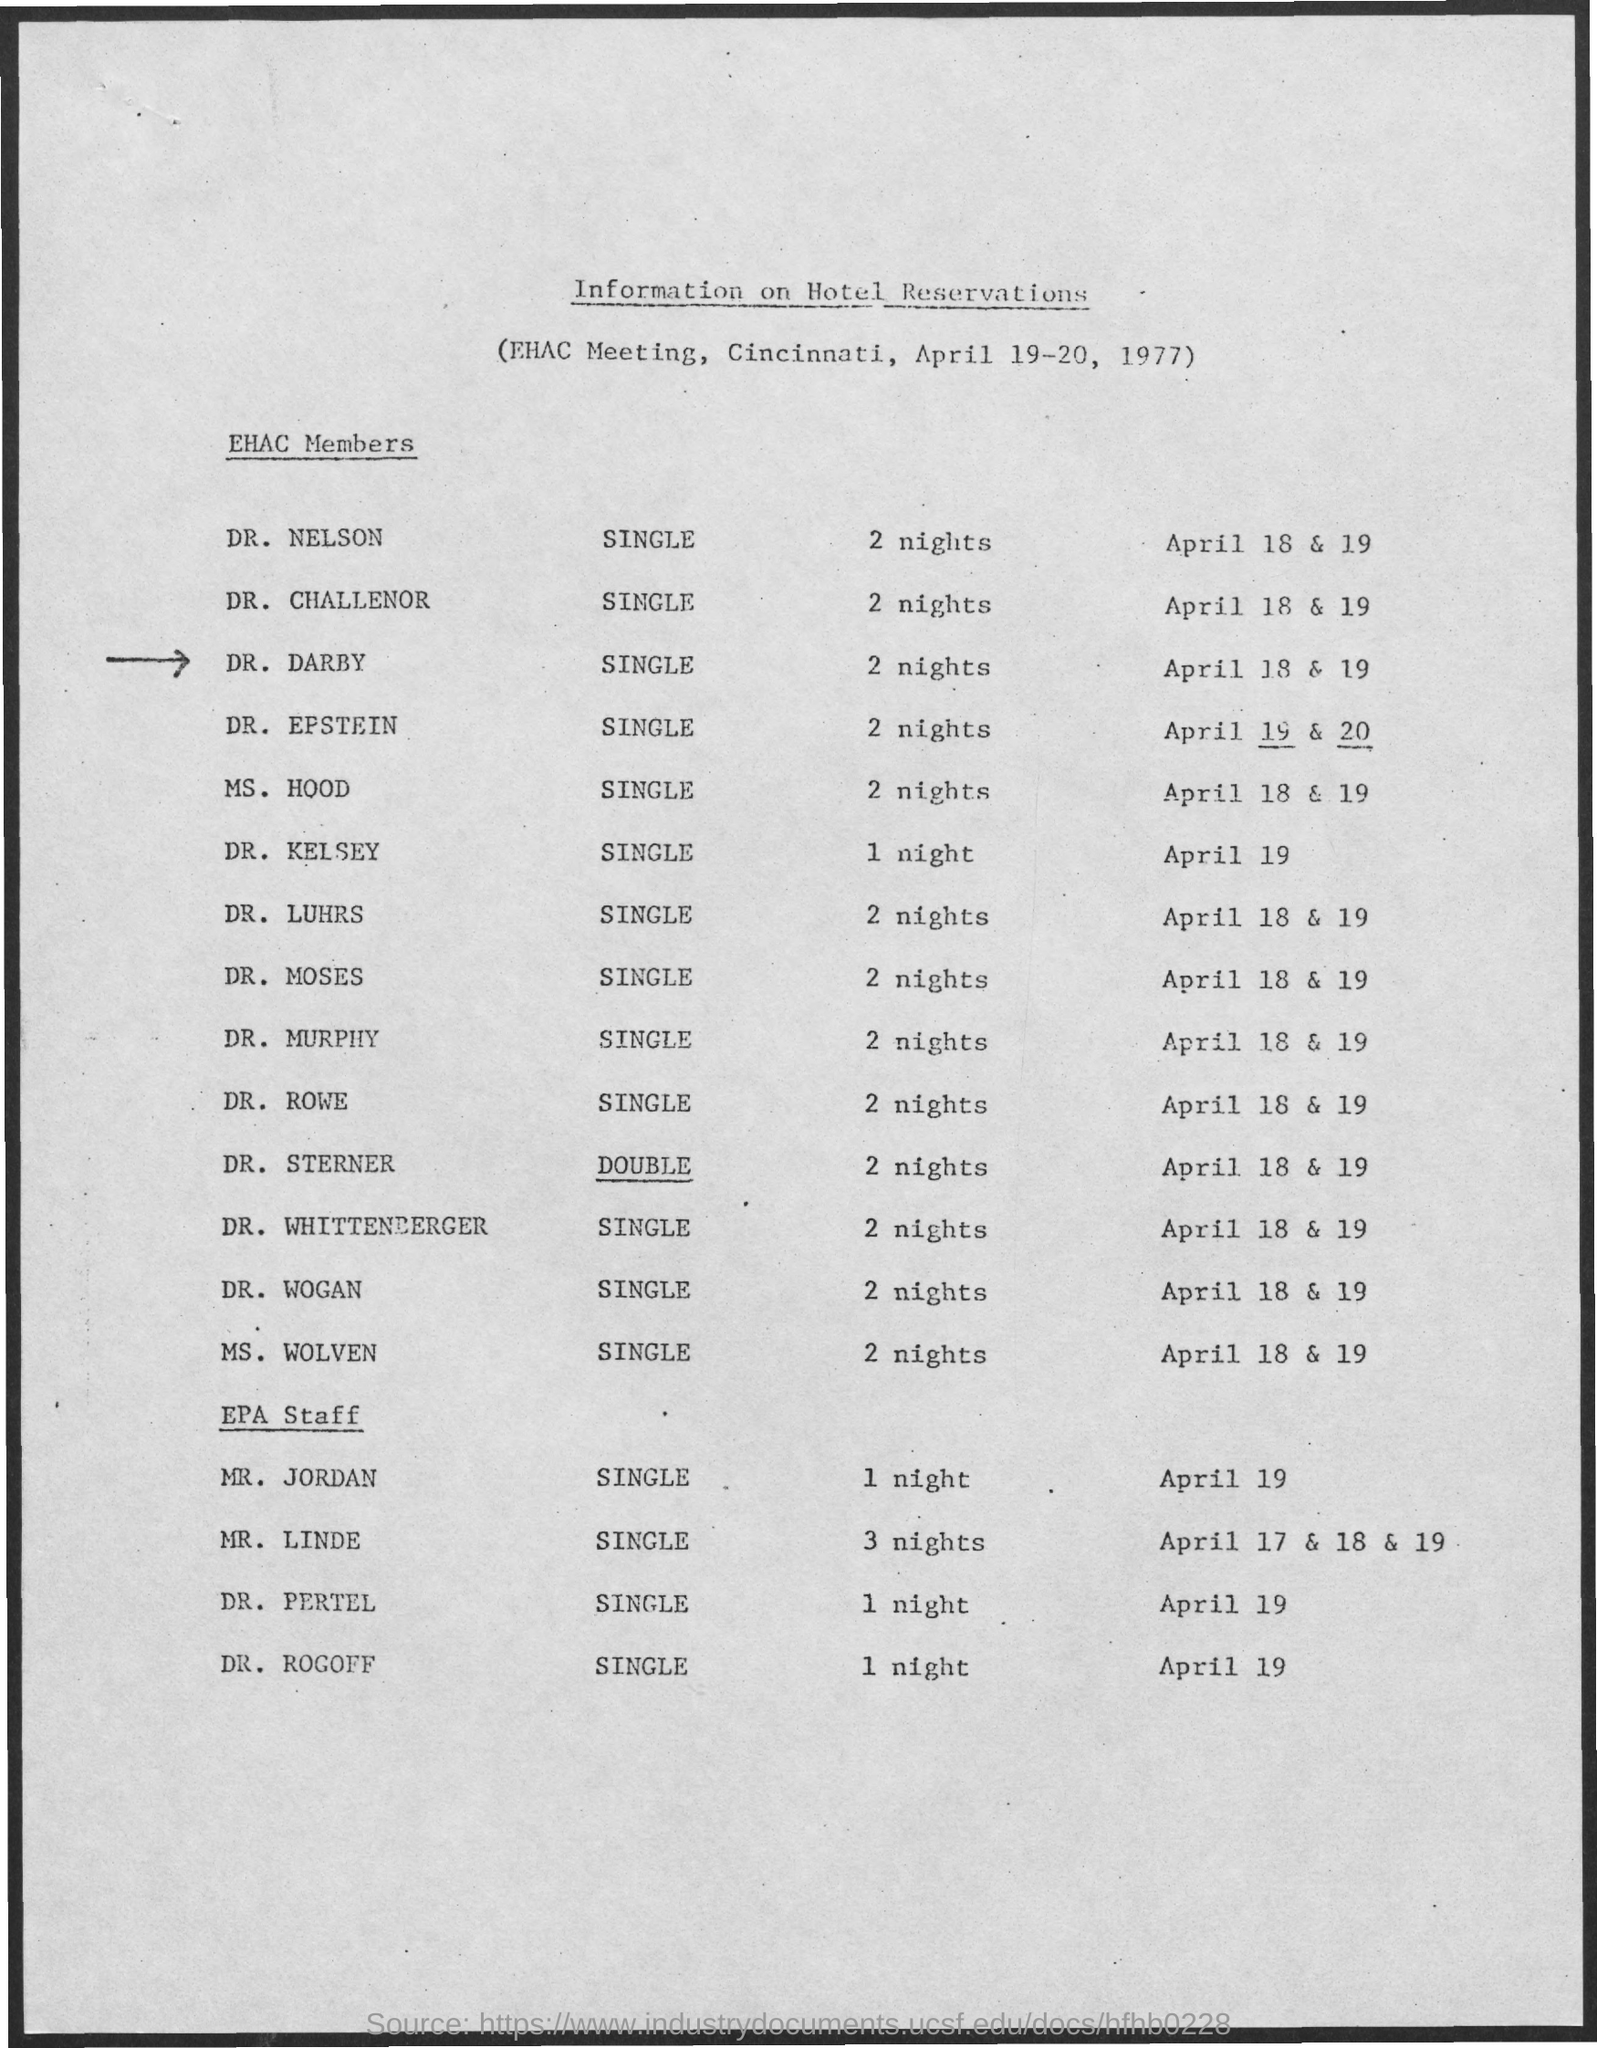Indicate a few pertinent items in this graphic. The document contains information on hotel reservations. On which date was hotel reservation done for DR. KELSEY? April 19th. The EHAC Meeting held in Cincinnati took place on April 19-20, 1977. The hotel reservation for DR. DARBY is booked for 2 nights. On April 17, 18, and 19, hotel reservations were made for Mr. Lind 